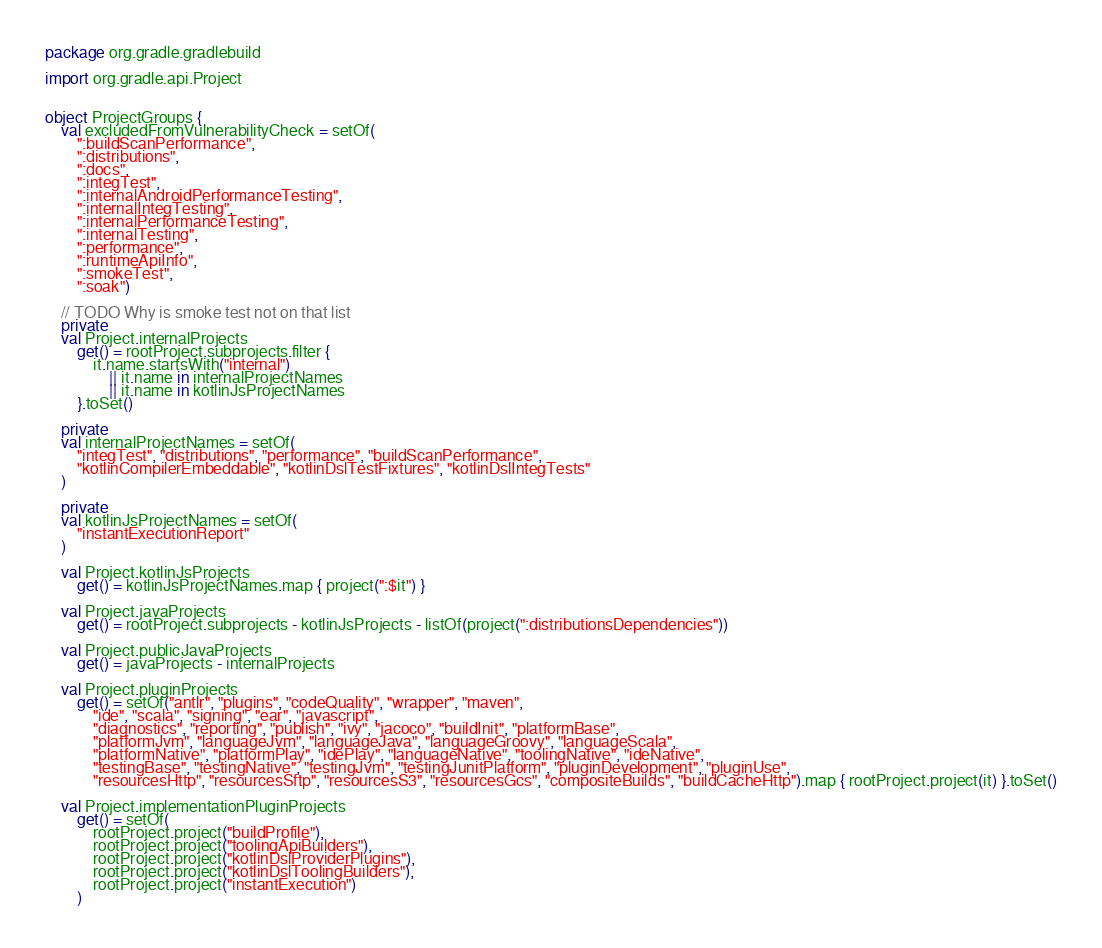Convert code to text. <code><loc_0><loc_0><loc_500><loc_500><_Kotlin_>package org.gradle.gradlebuild

import org.gradle.api.Project


object ProjectGroups {
    val excludedFromVulnerabilityCheck = setOf(
        ":buildScanPerformance",
        ":distributions",
        ":docs",
        ":integTest",
        ":internalAndroidPerformanceTesting",
        ":internalIntegTesting",
        ":internalPerformanceTesting",
        ":internalTesting",
        ":performance",
        ":runtimeApiInfo",
        ":smokeTest",
        ":soak")

    // TODO Why is smoke test not on that list
    private
    val Project.internalProjects
        get() = rootProject.subprojects.filter {
            it.name.startsWith("internal")
                || it.name in internalProjectNames
                || it.name in kotlinJsProjectNames
        }.toSet()

    private
    val internalProjectNames = setOf(
        "integTest", "distributions", "performance", "buildScanPerformance",
        "kotlinCompilerEmbeddable", "kotlinDslTestFixtures", "kotlinDslIntegTests"
    )

    private
    val kotlinJsProjectNames = setOf(
        "instantExecutionReport"
    )

    val Project.kotlinJsProjects
        get() = kotlinJsProjectNames.map { project(":$it") }

    val Project.javaProjects
        get() = rootProject.subprojects - kotlinJsProjects - listOf(project(":distributionsDependencies"))

    val Project.publicJavaProjects
        get() = javaProjects - internalProjects

    val Project.pluginProjects
        get() = setOf("antlr", "plugins", "codeQuality", "wrapper", "maven",
            "ide", "scala", "signing", "ear", "javascript",
            "diagnostics", "reporting", "publish", "ivy", "jacoco", "buildInit", "platformBase",
            "platformJvm", "languageJvm", "languageJava", "languageGroovy", "languageScala",
            "platformNative", "platformPlay", "idePlay", "languageNative", "toolingNative", "ideNative",
            "testingBase", "testingNative", "testingJvm", "testingJunitPlatform", "pluginDevelopment", "pluginUse",
            "resourcesHttp", "resourcesSftp", "resourcesS3", "resourcesGcs", "compositeBuilds", "buildCacheHttp").map { rootProject.project(it) }.toSet()

    val Project.implementationPluginProjects
        get() = setOf(
            rootProject.project("buildProfile"),
            rootProject.project("toolingApiBuilders"),
            rootProject.project("kotlinDslProviderPlugins"),
            rootProject.project("kotlinDslToolingBuilders"),
            rootProject.project("instantExecution")
        )
</code> 